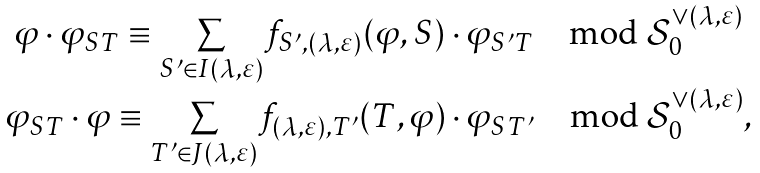<formula> <loc_0><loc_0><loc_500><loc_500>\begin{array} { c } \varphi \cdot \varphi _ { S T } \equiv \underset { S ^ { \prime } \in I ( \lambda , \varepsilon ) } { \sum } f _ { S ^ { \prime } , ( \lambda , \varepsilon ) } ( \varphi , S ) \cdot \varphi _ { S ^ { \prime } T } \mod \mathcal { S } _ { 0 } ^ { \vee ( \lambda , \varepsilon ) } \\ \varphi _ { S T } \cdot \varphi \equiv \underset { T ^ { \prime } \in J ( \lambda , \varepsilon ) } { \sum } f _ { ( \lambda , \varepsilon ) , T ^ { \prime } } ( T , \varphi ) \cdot \varphi _ { S T ^ { \prime } } \mod \mathcal { S } _ { 0 } ^ { \vee ( \lambda , \varepsilon ) } , \end{array}</formula> 